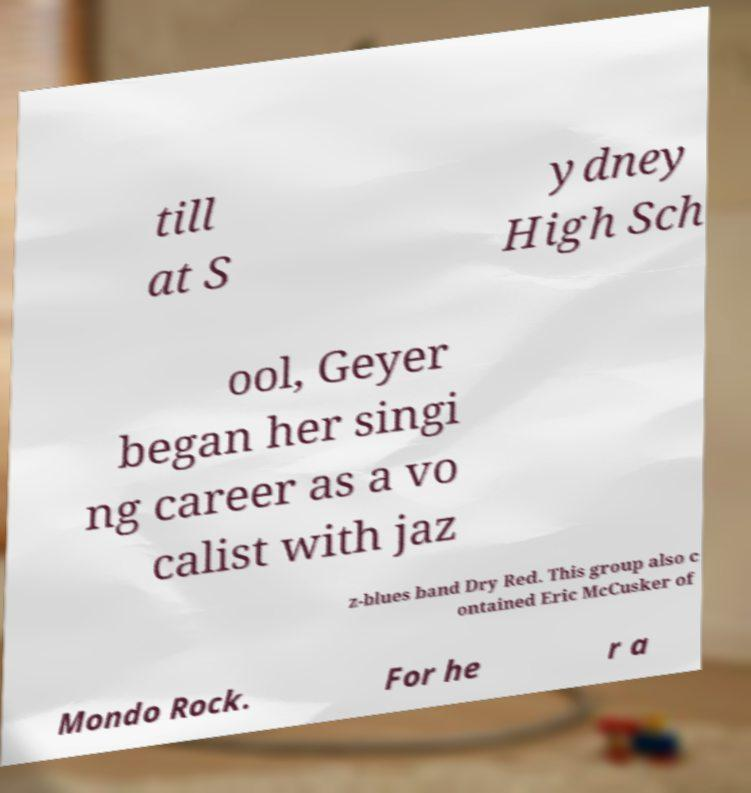Can you read and provide the text displayed in the image?This photo seems to have some interesting text. Can you extract and type it out for me? till at S ydney High Sch ool, Geyer began her singi ng career as a vo calist with jaz z-blues band Dry Red. This group also c ontained Eric McCusker of Mondo Rock. For he r a 